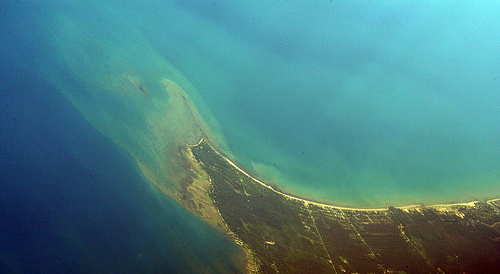<image>
Can you confirm if the sea is above the land? No. The sea is not positioned above the land. The vertical arrangement shows a different relationship. 